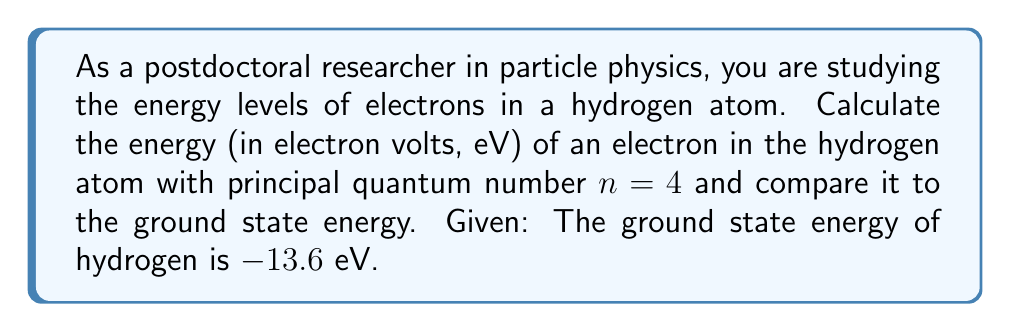Provide a solution to this math problem. To solve this problem, we'll use the Bohr model of the hydrogen atom, which relates the energy levels to the principal quantum number n.

1) The energy of an electron in a hydrogen atom is given by the formula:

   $$E_n = -\frac{13.6 \text{ eV}}{n^2}$$

   Where $E_n$ is the energy of the electron in the nth energy level, and n is the principal quantum number.

2) For the ground state (n = 1):
   
   $$E_1 = -\frac{13.6 \text{ eV}}{1^2} = -13.6 \text{ eV}$$

3) For n = 4:
   
   $$E_4 = -\frac{13.6 \text{ eV}}{4^2} = -\frac{13.6 \text{ eV}}{16} = -0.85 \text{ eV}$$

4) To compare with the ground state, we can calculate the difference:

   $$\Delta E = E_4 - E_1 = -0.85 \text{ eV} - (-13.6 \text{ eV}) = 12.75 \text{ eV}$$

This positive energy difference indicates that the n = 4 state is higher in energy than the ground state, as expected.
Answer: The energy of an electron in the hydrogen atom with n = 4 is -0.85 eV. This is 12.75 eV higher than the ground state energy. 